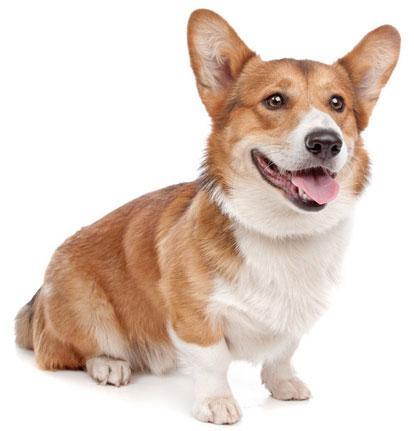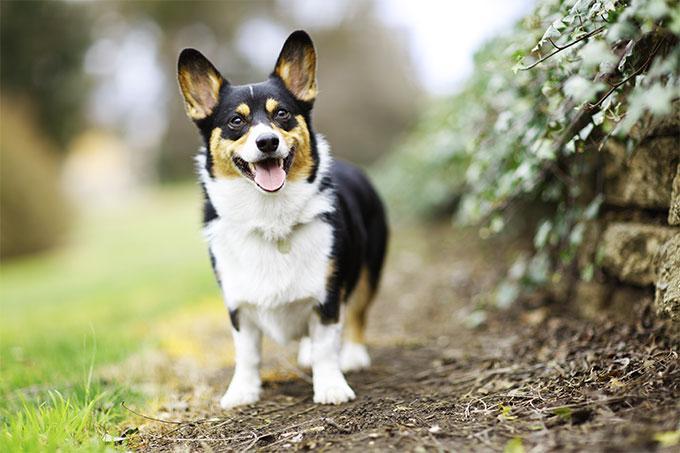The first image is the image on the left, the second image is the image on the right. Assess this claim about the two images: "At least one dog has its mouth completely closed.". Correct or not? Answer yes or no. No. The first image is the image on the left, the second image is the image on the right. Assess this claim about the two images: "All dogs are looking in the general direction of the camera.". Correct or not? Answer yes or no. Yes. The first image is the image on the left, the second image is the image on the right. Given the left and right images, does the statement "Right image shows one short-legged dog standing outdoors." hold true? Answer yes or no. Yes. The first image is the image on the left, the second image is the image on the right. Assess this claim about the two images: "The image on the right has a one dog with its tongue showing.". Correct or not? Answer yes or no. Yes. 